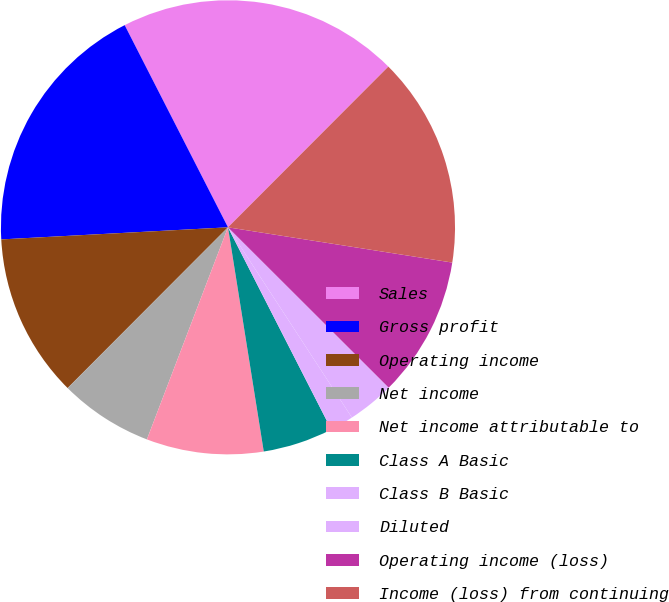<chart> <loc_0><loc_0><loc_500><loc_500><pie_chart><fcel>Sales<fcel>Gross profit<fcel>Operating income<fcel>Net income<fcel>Net income attributable to<fcel>Class A Basic<fcel>Class B Basic<fcel>Diluted<fcel>Operating income (loss)<fcel>Income (loss) from continuing<nl><fcel>20.0%<fcel>18.33%<fcel>11.67%<fcel>6.67%<fcel>8.33%<fcel>5.0%<fcel>1.67%<fcel>3.33%<fcel>10.0%<fcel>15.0%<nl></chart> 